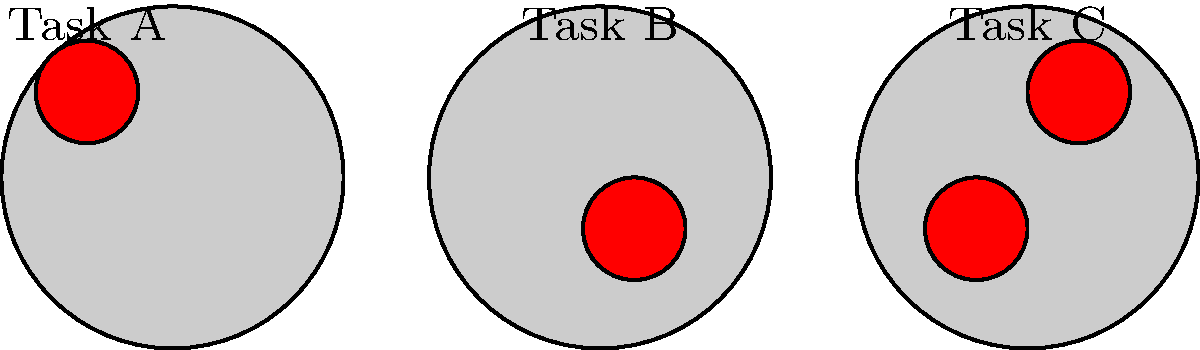Look at the simplified PET scan images above. Each image shows brain activity during a different task. Which task activates multiple areas of the brain? To answer this question, we need to examine each PET scan image carefully:

1. Task A: This image shows one red area of activation in the upper left part of the brain.

2. Task B: This image shows one red area of activation in the lower right part of the brain.

3. Task C: This image shows two red areas of activation - one in the upper right and one in the lower left part of the brain.

The red areas in these simplified PET scan images represent active brain regions during each task. To determine which task activates multiple areas of the brain, we need to count the number of red areas in each image.

Task A and Task B both show only one red area, indicating that they each activate a single brain region.

Task C, however, shows two distinct red areas, which means it activates multiple areas of the brain.

Therefore, the task that activates multiple areas of the brain is Task C.
Answer: Task C 